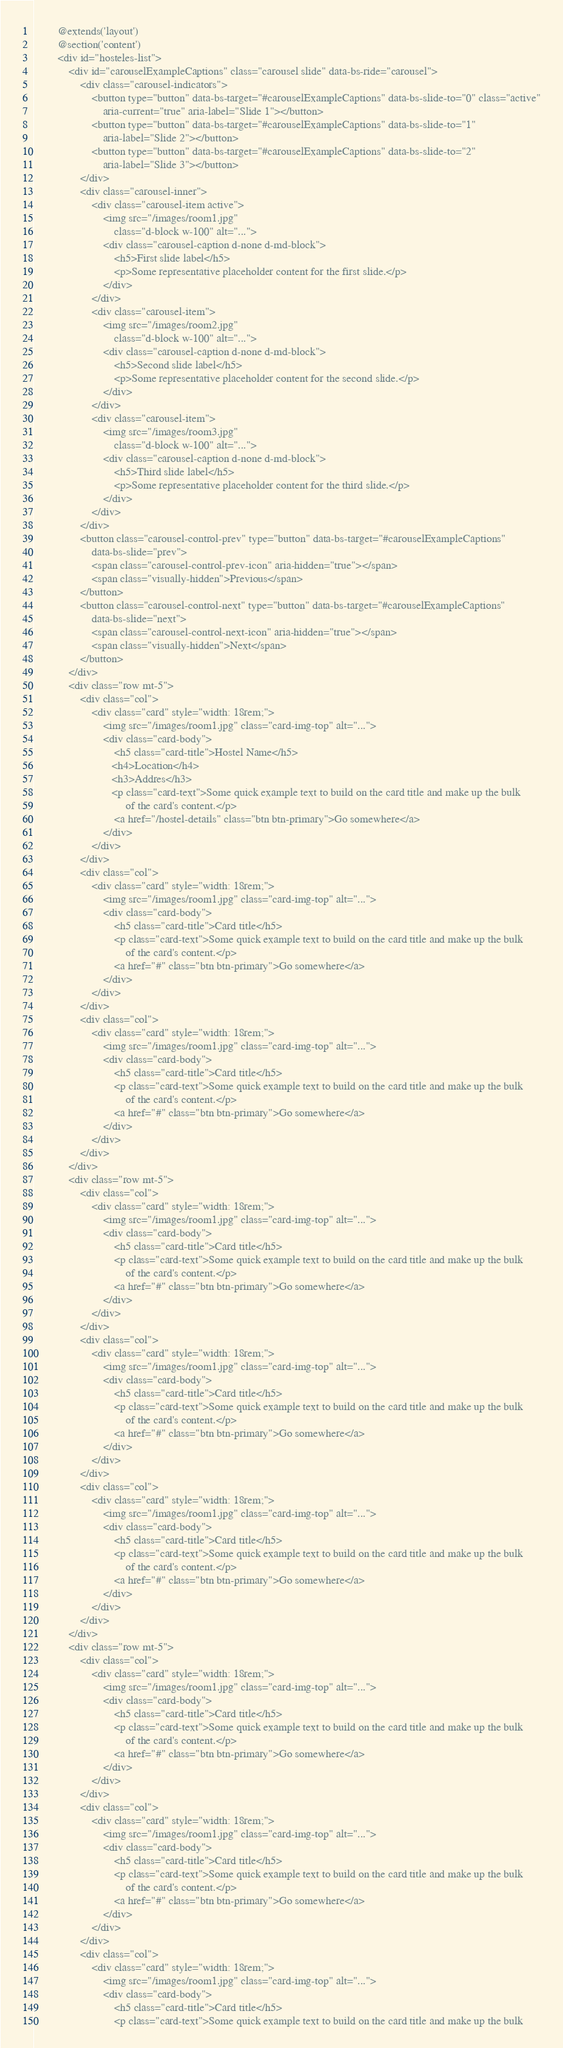<code> <loc_0><loc_0><loc_500><loc_500><_PHP_>
        @extends('layout')
        @section('content')
        <div id="hosteles-list">
            <div id="carouselExampleCaptions" class="carousel slide" data-bs-ride="carousel">
                <div class="carousel-indicators">
                    <button type="button" data-bs-target="#carouselExampleCaptions" data-bs-slide-to="0" class="active"
                        aria-current="true" aria-label="Slide 1"></button>
                    <button type="button" data-bs-target="#carouselExampleCaptions" data-bs-slide-to="1"
                        aria-label="Slide 2"></button>
                    <button type="button" data-bs-target="#carouselExampleCaptions" data-bs-slide-to="2"
                        aria-label="Slide 3"></button>
                </div>
                <div class="carousel-inner">
                    <div class="carousel-item active">
                        <img src="/images/room1.jpg"
                            class="d-block w-100" alt="...">
                        <div class="carousel-caption d-none d-md-block">
                            <h5>First slide label</h5>
                            <p>Some representative placeholder content for the first slide.</p>
                        </div>
                    </div>
                    <div class="carousel-item">
                        <img src="/images/room2.jpg"
                            class="d-block w-100" alt="...">
                        <div class="carousel-caption d-none d-md-block">
                            <h5>Second slide label</h5>
                            <p>Some representative placeholder content for the second slide.</p>
                        </div>
                    </div>
                    <div class="carousel-item">
                        <img src="/images/room3.jpg"
                            class="d-block w-100" alt="...">
                        <div class="carousel-caption d-none d-md-block">
                            <h5>Third slide label</h5>
                            <p>Some representative placeholder content for the third slide.</p>
                        </div>
                    </div>
                </div>
                <button class="carousel-control-prev" type="button" data-bs-target="#carouselExampleCaptions"
                    data-bs-slide="prev">
                    <span class="carousel-control-prev-icon" aria-hidden="true"></span>
                    <span class="visually-hidden">Previous</span>
                </button>
                <button class="carousel-control-next" type="button" data-bs-target="#carouselExampleCaptions"
                    data-bs-slide="next">
                    <span class="carousel-control-next-icon" aria-hidden="true"></span>
                    <span class="visually-hidden">Next</span>
                </button>
            </div>
            <div class="row mt-5">
                <div class="col">
                    <div class="card" style="width: 18rem;">
                        <img src="/images/room1.jpg" class="card-img-top" alt="...">
                        <div class="card-body">
                            <h5 class="card-title">Hostel Name</h5>
                           <h4>Location</h4>
                           <h3>Addres</h3>
                           <p class="card-text">Some quick example text to build on the card title and make up the bulk
                                of the card's content.</p>
                            <a href="/hostel-details" class="btn btn-primary">Go somewhere</a>
                        </div>
                    </div>
                </div>
                <div class="col">
                    <div class="card" style="width: 18rem;">
                        <img src="/images/room1.jpg" class="card-img-top" alt="...">
                        <div class="card-body">
                            <h5 class="card-title">Card title</h5>
                            <p class="card-text">Some quick example text to build on the card title and make up the bulk
                                of the card's content.</p>
                            <a href="#" class="btn btn-primary">Go somewhere</a>
                        </div>
                    </div>
                </div>
                <div class="col">
                    <div class="card" style="width: 18rem;">
                        <img src="/images/room1.jpg" class="card-img-top" alt="...">
                        <div class="card-body">
                            <h5 class="card-title">Card title</h5>
                            <p class="card-text">Some quick example text to build on the card title and make up the bulk
                                of the card's content.</p>
                            <a href="#" class="btn btn-primary">Go somewhere</a>
                        </div>
                    </div>
                </div>
            </div>
            <div class="row mt-5">
                <div class="col">
                    <div class="card" style="width: 18rem;">
                        <img src="/images/room1.jpg" class="card-img-top" alt="...">
                        <div class="card-body">
                            <h5 class="card-title">Card title</h5>
                            <p class="card-text">Some quick example text to build on the card title and make up the bulk
                                of the card's content.</p>
                            <a href="#" class="btn btn-primary">Go somewhere</a>
                        </div>
                    </div>
                </div>
                <div class="col">
                    <div class="card" style="width: 18rem;">
                        <img src="/images/room1.jpg" class="card-img-top" alt="...">
                        <div class="card-body">
                            <h5 class="card-title">Card title</h5>
                            <p class="card-text">Some quick example text to build on the card title and make up the bulk
                                of the card's content.</p>
                            <a href="#" class="btn btn-primary">Go somewhere</a>
                        </div>
                    </div>
                </div>
                <div class="col">
                    <div class="card" style="width: 18rem;">
                        <img src="/images/room1.jpg" class="card-img-top" alt="...">
                        <div class="card-body">
                            <h5 class="card-title">Card title</h5>
                            <p class="card-text">Some quick example text to build on the card title and make up the bulk
                                of the card's content.</p>
                            <a href="#" class="btn btn-primary">Go somewhere</a>
                        </div>
                    </div>
                </div>
            </div>
            <div class="row mt-5">
                <div class="col">
                    <div class="card" style="width: 18rem;">
                        <img src="/images/room1.jpg" class="card-img-top" alt="...">
                        <div class="card-body">
                            <h5 class="card-title">Card title</h5>
                            <p class="card-text">Some quick example text to build on the card title and make up the bulk
                                of the card's content.</p>
                            <a href="#" class="btn btn-primary">Go somewhere</a>
                        </div>
                    </div>
                </div>
                <div class="col">
                    <div class="card" style="width: 18rem;">
                        <img src="/images/room1.jpg" class="card-img-top" alt="...">
                        <div class="card-body">
                            <h5 class="card-title">Card title</h5>
                            <p class="card-text">Some quick example text to build on the card title and make up the bulk
                                of the card's content.</p>
                            <a href="#" class="btn btn-primary">Go somewhere</a>
                        </div>
                    </div>
                </div>
                <div class="col">
                    <div class="card" style="width: 18rem;">
                        <img src="/images/room1.jpg" class="card-img-top" alt="...">
                        <div class="card-body">
                            <h5 class="card-title">Card title</h5>
                            <p class="card-text">Some quick example text to build on the card title and make up the bulk</code> 